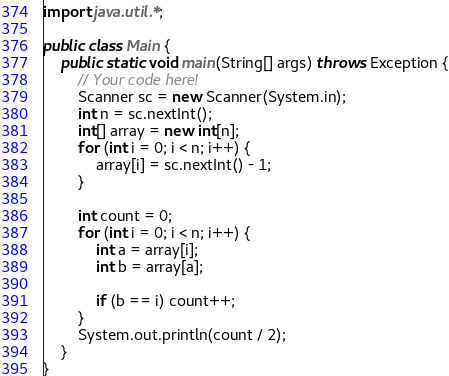Convert code to text. <code><loc_0><loc_0><loc_500><loc_500><_Java_>import java.util.*;

public class Main {
    public static void main(String[] args) throws Exception {
        // Your code here!
        Scanner sc = new Scanner(System.in);
        int n = sc.nextInt();
        int[] array = new int[n];
        for (int i = 0; i < n; i++) {
            array[i] = sc.nextInt() - 1;
        }
        
        int count = 0;
        for (int i = 0; i < n; i++) {
            int a = array[i];
            int b = array[a];
            
            if (b == i) count++;
        }
        System.out.println(count / 2);
    }
}
</code> 